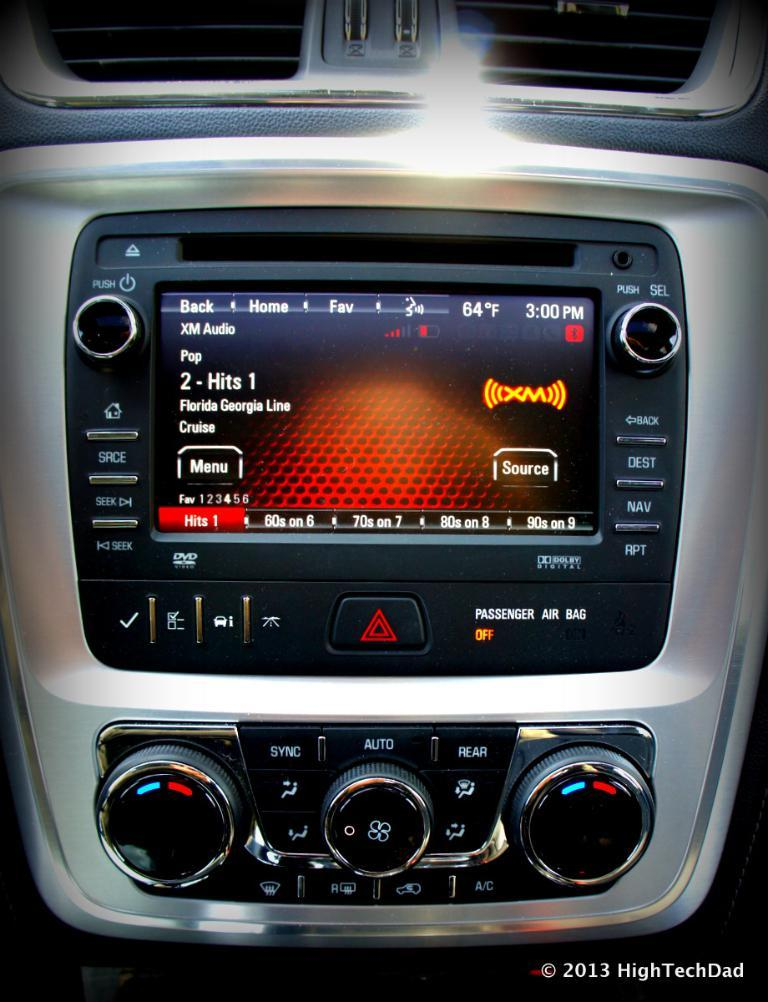What is the main subject of the image? The main subject of the image is a car stereo music system. Is there any additional information or markings in the image? Yes, there is a watermark in the image. How many fingers are touching the car stereo in the image? There are no fingers touching the car stereo in the image. What type of doctor is present in the image? There are no doctors present in the image. 